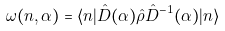Convert formula to latex. <formula><loc_0><loc_0><loc_500><loc_500>\omega ( n , \alpha ) = \langle n | \hat { D } ( \alpha ) \hat { \rho } \hat { D } ^ { - 1 } ( \alpha ) | n \rangle</formula> 